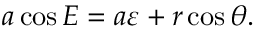Convert formula to latex. <formula><loc_0><loc_0><loc_500><loc_500>a \cos E = a \varepsilon + r \cos \theta .</formula> 